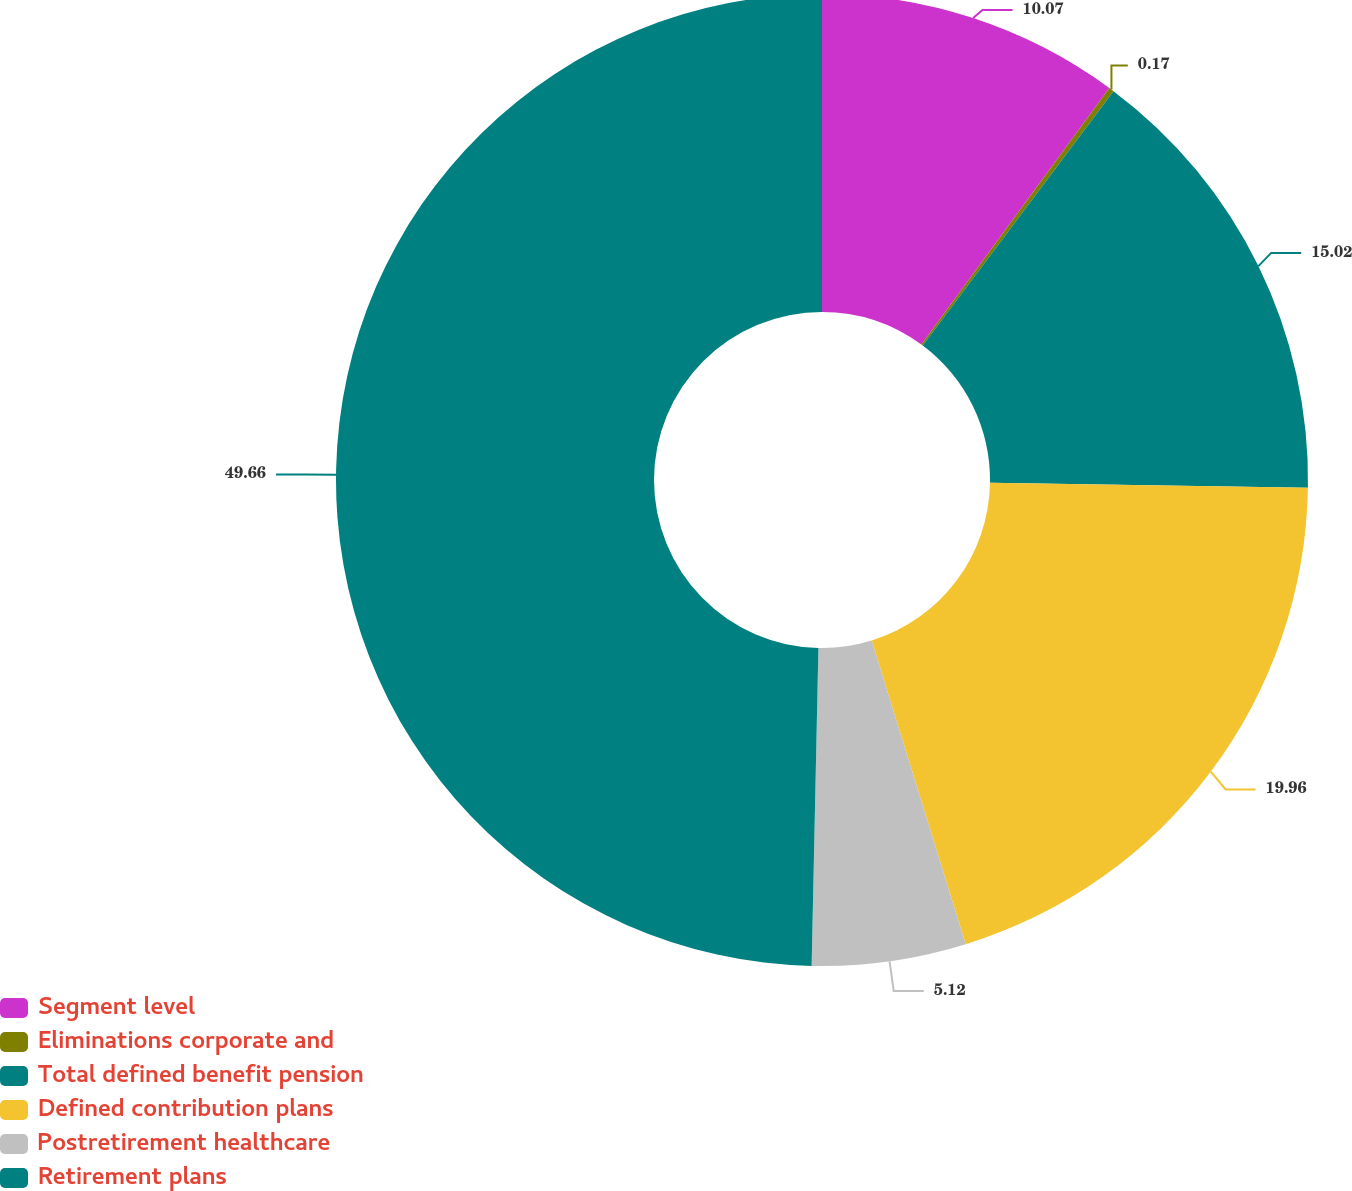Convert chart to OTSL. <chart><loc_0><loc_0><loc_500><loc_500><pie_chart><fcel>Segment level<fcel>Eliminations corporate and<fcel>Total defined benefit pension<fcel>Defined contribution plans<fcel>Postretirement healthcare<fcel>Retirement plans<nl><fcel>10.07%<fcel>0.17%<fcel>15.02%<fcel>19.97%<fcel>5.12%<fcel>49.67%<nl></chart> 